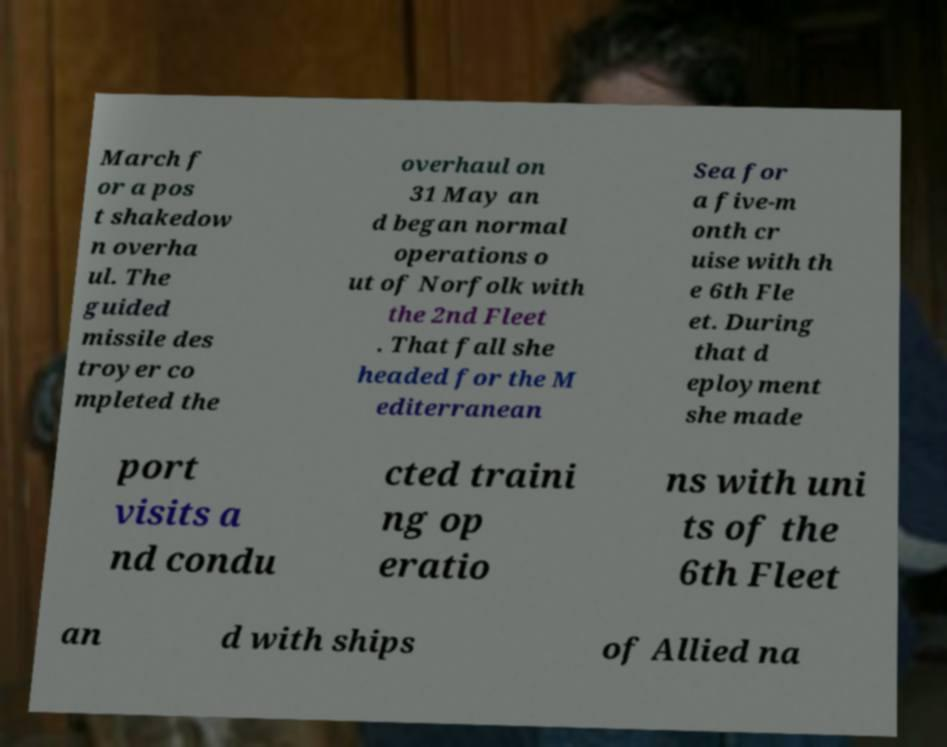For documentation purposes, I need the text within this image transcribed. Could you provide that? March f or a pos t shakedow n overha ul. The guided missile des troyer co mpleted the overhaul on 31 May an d began normal operations o ut of Norfolk with the 2nd Fleet . That fall she headed for the M editerranean Sea for a five-m onth cr uise with th e 6th Fle et. During that d eployment she made port visits a nd condu cted traini ng op eratio ns with uni ts of the 6th Fleet an d with ships of Allied na 